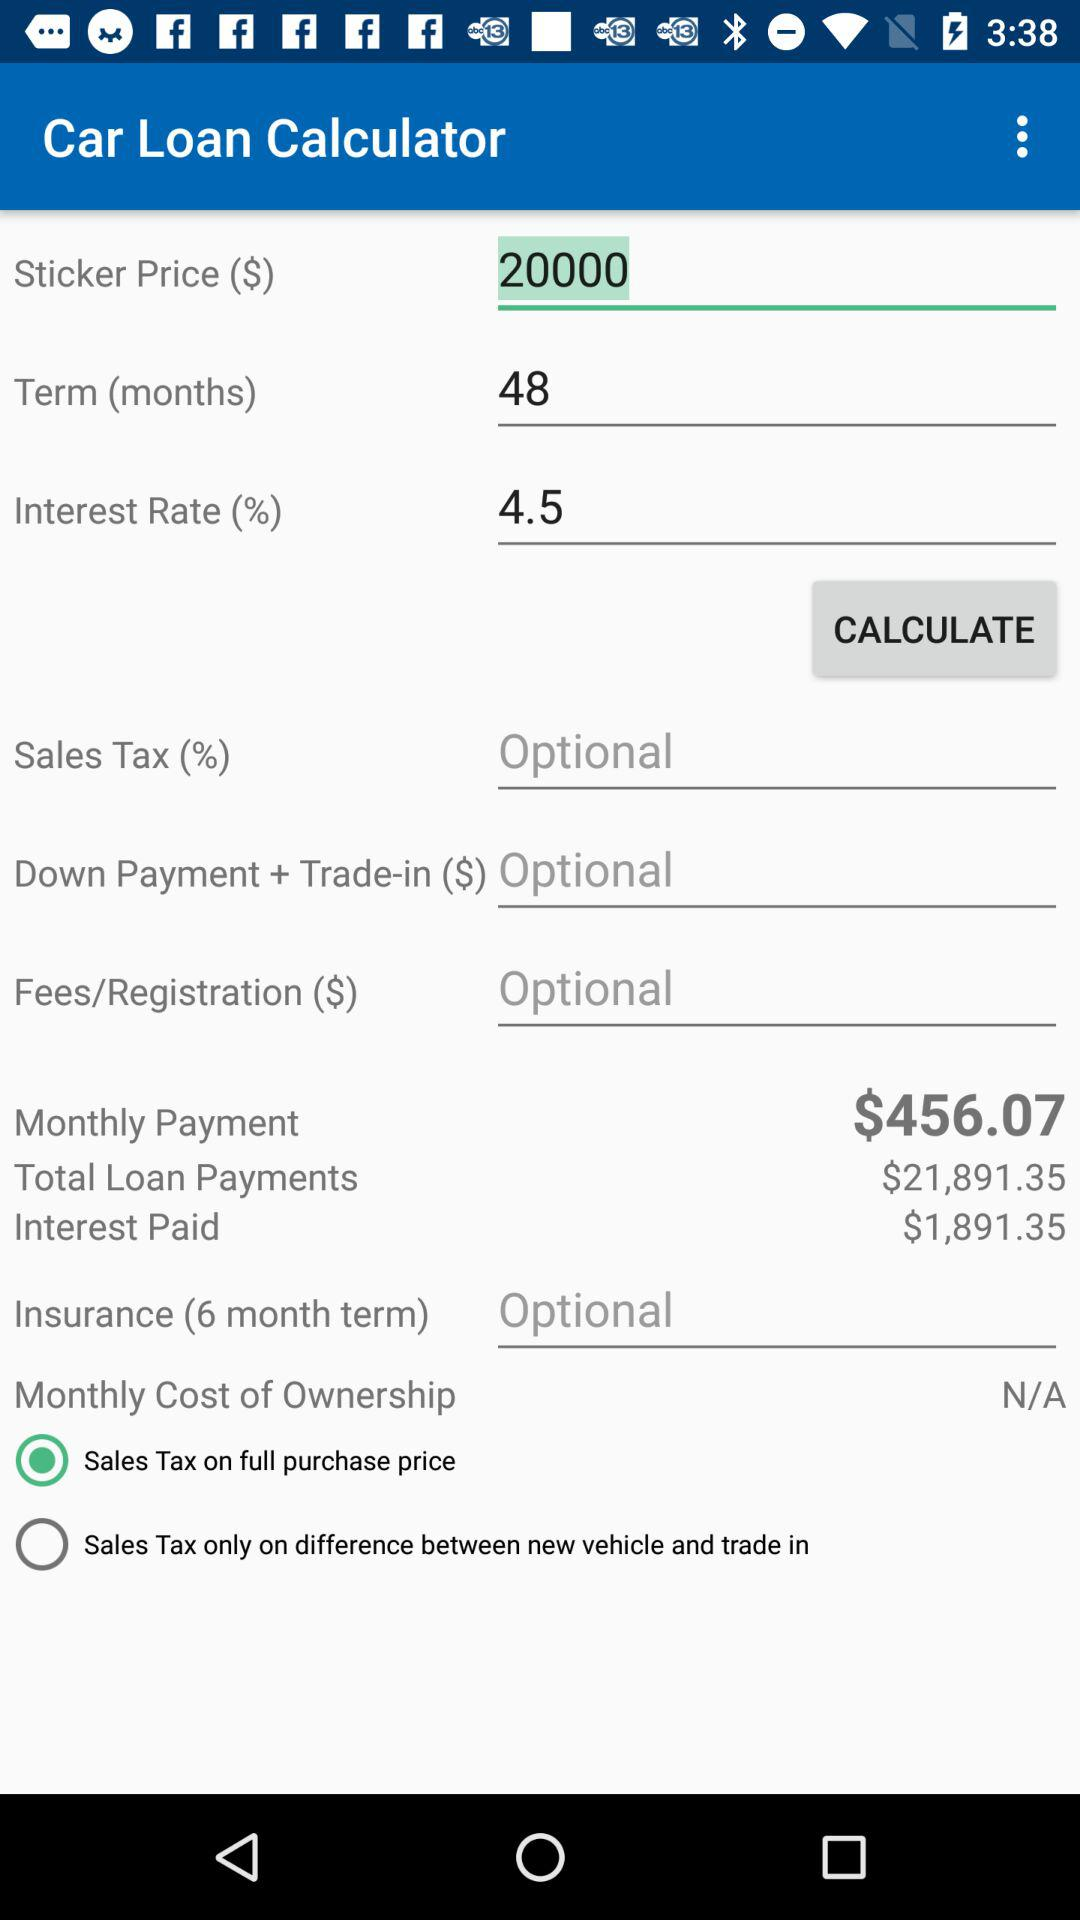How much is the total loan payment amount? The total loan payment amount is $21,891.35. 